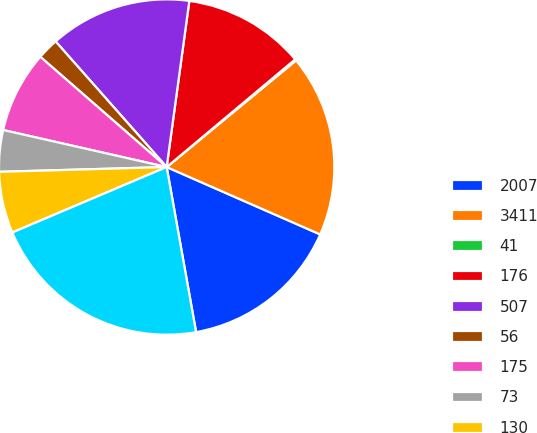Convert chart to OTSL. <chart><loc_0><loc_0><loc_500><loc_500><pie_chart><fcel>2007<fcel>3411<fcel>41<fcel>176<fcel>507<fcel>56<fcel>175<fcel>73<fcel>130<fcel>4569<nl><fcel>15.61%<fcel>17.55%<fcel>0.13%<fcel>11.74%<fcel>13.68%<fcel>2.06%<fcel>7.87%<fcel>4.0%<fcel>5.93%<fcel>21.42%<nl></chart> 